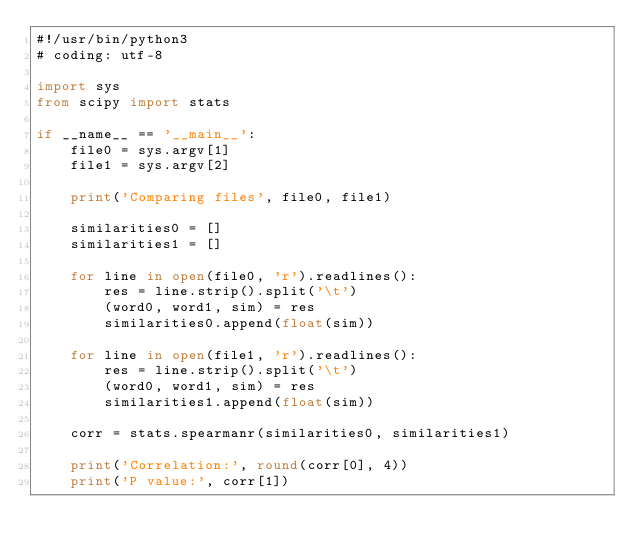<code> <loc_0><loc_0><loc_500><loc_500><_Python_>#!/usr/bin/python3
# coding: utf-8

import sys
from scipy import stats

if __name__ == '__main__':
    file0 = sys.argv[1]
    file1 = sys.argv[2]

    print('Comparing files', file0, file1)

    similarities0 = []
    similarities1 = []

    for line in open(file0, 'r').readlines():
        res = line.strip().split('\t')
        (word0, word1, sim) = res
        similarities0.append(float(sim))

    for line in open(file1, 'r').readlines():
        res = line.strip().split('\t')
        (word0, word1, sim) = res
        similarities1.append(float(sim))

    corr = stats.spearmanr(similarities0, similarities1)

    print('Correlation:', round(corr[0], 4))
    print('P value:', corr[1])
</code> 